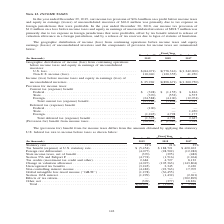From Sunpower Corporation's financial document, In which years was the income taxes recorded for? The document contains multiple relevant values: 2019, 2018, 2017. From the document: "December 29, 2019 December 30, 2018 December 31, 2017 Geographic distribution of income (loss) from continuing operations before income taxes and equi..." Also, What was the income tax provision on equity in earnings (losses) of unconsolidated investees in 2019? According to the financial document, $26.0 million. The relevant text states: "n earnings (losses) of unconsolidated investees of $26.0 million was primarily due to tax expense in foreign jurisdictions that were profitable. In the year ended De..." Also, What was the state deferred tax (expense) benefit in 2017? According to the financial document, 1,450 (in thousands). The relevant text states: "(expense) benefit Federal . (100) — — State . — — 1,450 Foreign. . (1,245) 4,798 1,177 Total deferred tax (expense) benefit . (1,345) 4,798 2,627 (Provisio..." Additionally, Which year was the total current tax benefit the highest? According to the financial document, 2017. The relevant text states: "December 29, 2019 December 30, 2018 December 31, 2017 Geographic distribution of income (loss) from continuing operations before income taxes and equity..." Also, can you calculate: What was the change in federal deferred tax  benefit from 2018 to 2019? Based on the calculation: -100 - 0 , the result is -100 (in thousands). This is based on the information: "State . (370) (553) 6,575 Foreign. . (24,588) (4,100) (12,074) Total current tax (expense) benefit . (25,286) (5,808) 1,317 Deferred tax (expense) benef State . (370) (553) 6,575 Foreign. . (24,588) (..." Also, can you calculate: What was the percentage change in Total deferred tax benefit  from 2017 to 2018? To answer this question, I need to perform calculations using the financial data. The calculation is: (4,798- 2,627)/ 2,627  , which equals 82.64 (percentage). This is based on the information: "al deferred tax (expense) benefit . (1,345) 4,798 2,627 (Provision for) benefit from income taxes . (26,631) $ (1,010) $ 3,944 . (100) — — State . — — 1,450 Foreign. . (1,245) 4,798 1,177 Total deferr..." The key data points involved are: 2,627, 4,798. 